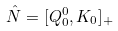<formula> <loc_0><loc_0><loc_500><loc_500>\hat { N } = [ Q _ { 0 } ^ { 0 } , K _ { 0 } ] _ { + }</formula> 